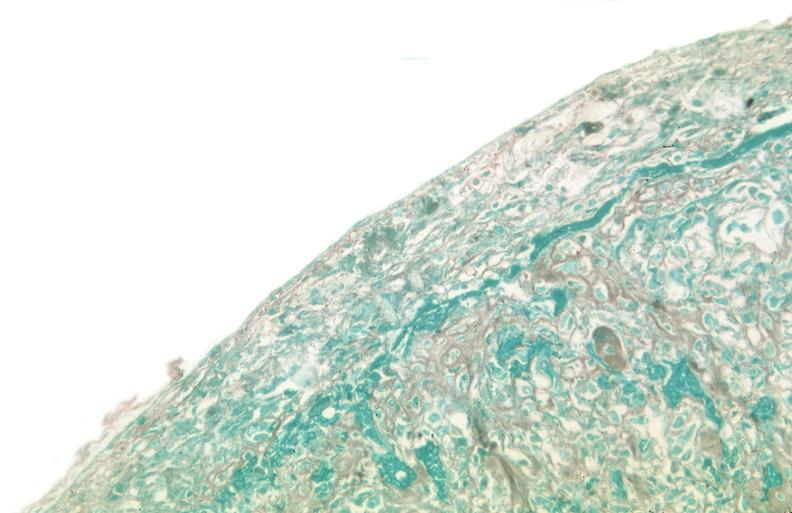where is this?
Answer the question using a single word or phrase. Lung 